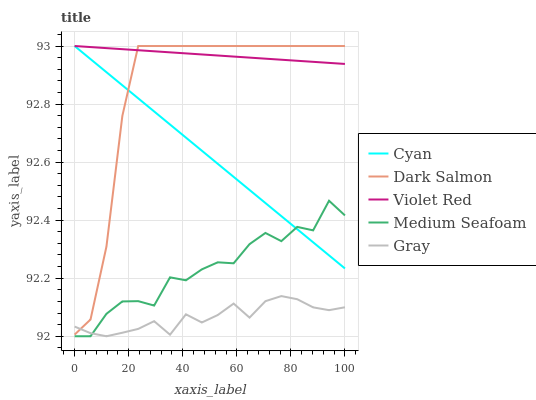Does Gray have the minimum area under the curve?
Answer yes or no. Yes. Does Violet Red have the maximum area under the curve?
Answer yes or no. Yes. Does Violet Red have the minimum area under the curve?
Answer yes or no. No. Does Gray have the maximum area under the curve?
Answer yes or no. No. Is Violet Red the smoothest?
Answer yes or no. Yes. Is Medium Seafoam the roughest?
Answer yes or no. Yes. Is Gray the smoothest?
Answer yes or no. No. Is Gray the roughest?
Answer yes or no. No. Does Gray have the lowest value?
Answer yes or no. Yes. Does Violet Red have the lowest value?
Answer yes or no. No. Does Dark Salmon have the highest value?
Answer yes or no. Yes. Does Gray have the highest value?
Answer yes or no. No. Is Medium Seafoam less than Dark Salmon?
Answer yes or no. Yes. Is Dark Salmon greater than Medium Seafoam?
Answer yes or no. Yes. Does Gray intersect Medium Seafoam?
Answer yes or no. Yes. Is Gray less than Medium Seafoam?
Answer yes or no. No. Is Gray greater than Medium Seafoam?
Answer yes or no. No. Does Medium Seafoam intersect Dark Salmon?
Answer yes or no. No. 